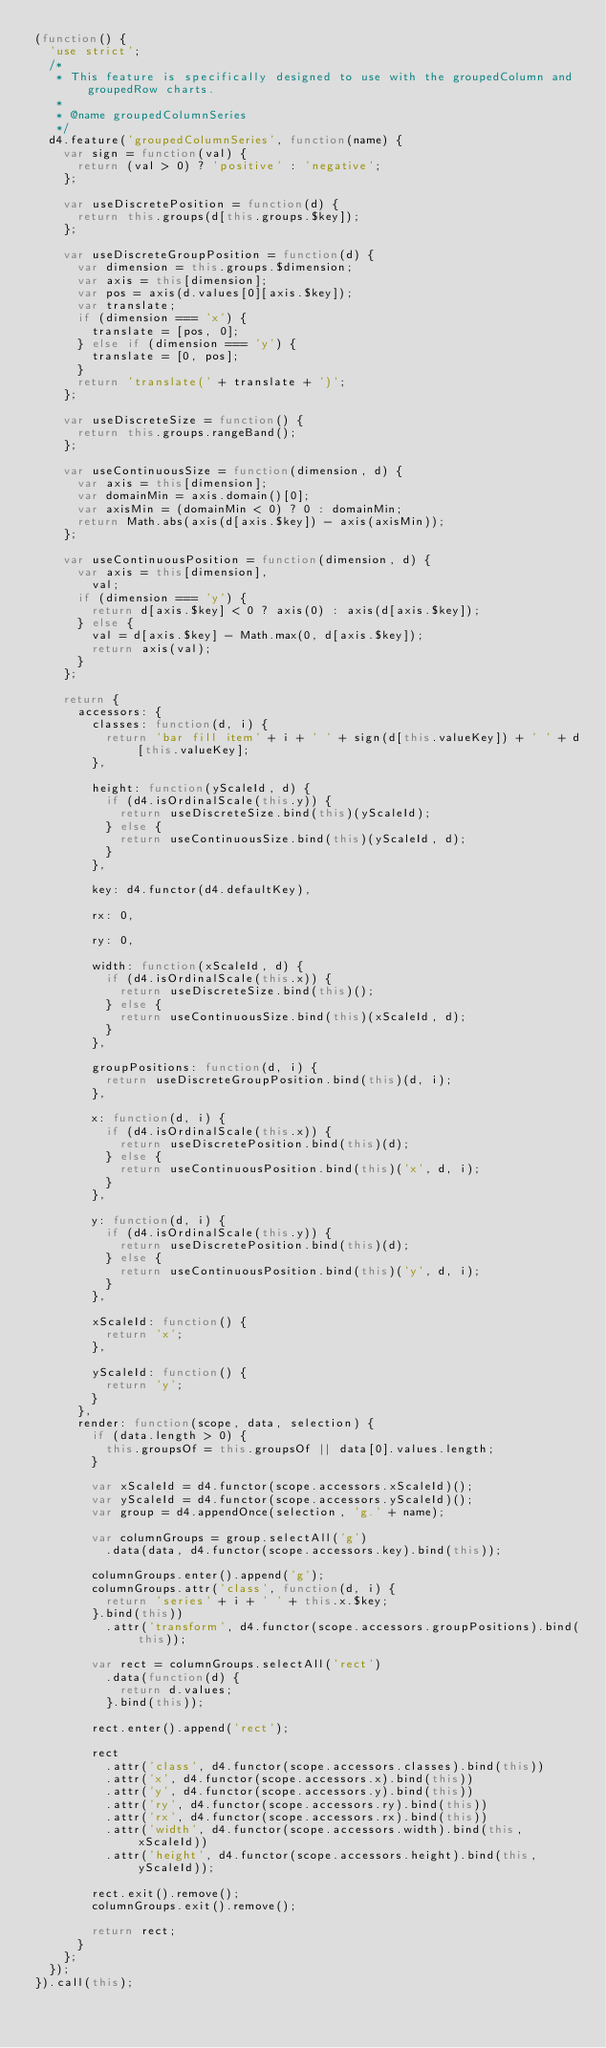<code> <loc_0><loc_0><loc_500><loc_500><_JavaScript_>(function() {
  'use strict';
  /*
   * This feature is specifically designed to use with the groupedColumn and groupedRow charts.
   *
   * @name groupedColumnSeries
   */
  d4.feature('groupedColumnSeries', function(name) {
    var sign = function(val) {
      return (val > 0) ? 'positive' : 'negative';
    };

    var useDiscretePosition = function(d) {
      return this.groups(d[this.groups.$key]);
    };

    var useDiscreteGroupPosition = function(d) {
      var dimension = this.groups.$dimension;
      var axis = this[dimension];
      var pos = axis(d.values[0][axis.$key]);
      var translate;
      if (dimension === 'x') {
        translate = [pos, 0];
      } else if (dimension === 'y') {
        translate = [0, pos];
      }
      return 'translate(' + translate + ')';
    };

    var useDiscreteSize = function() {
      return this.groups.rangeBand();
    };

    var useContinuousSize = function(dimension, d) {
      var axis = this[dimension];
      var domainMin = axis.domain()[0];
      var axisMin = (domainMin < 0) ? 0 : domainMin;
      return Math.abs(axis(d[axis.$key]) - axis(axisMin));
    };

    var useContinuousPosition = function(dimension, d) {
      var axis = this[dimension],
        val;
      if (dimension === 'y') {
        return d[axis.$key] < 0 ? axis(0) : axis(d[axis.$key]);
      } else {
        val = d[axis.$key] - Math.max(0, d[axis.$key]);
        return axis(val);
      }
    };

    return {
      accessors: {
        classes: function(d, i) {
          return 'bar fill item' + i + ' ' + sign(d[this.valueKey]) + ' ' + d[this.valueKey];
        },

        height: function(yScaleId, d) {
          if (d4.isOrdinalScale(this.y)) {
            return useDiscreteSize.bind(this)(yScaleId);
          } else {
            return useContinuousSize.bind(this)(yScaleId, d);
          }
        },

        key: d4.functor(d4.defaultKey),

        rx: 0,

        ry: 0,

        width: function(xScaleId, d) {
          if (d4.isOrdinalScale(this.x)) {
            return useDiscreteSize.bind(this)();
          } else {
            return useContinuousSize.bind(this)(xScaleId, d);
          }
        },

        groupPositions: function(d, i) {
          return useDiscreteGroupPosition.bind(this)(d, i);
        },

        x: function(d, i) {
          if (d4.isOrdinalScale(this.x)) {
            return useDiscretePosition.bind(this)(d);
          } else {
            return useContinuousPosition.bind(this)('x', d, i);
          }
        },

        y: function(d, i) {
          if (d4.isOrdinalScale(this.y)) {
            return useDiscretePosition.bind(this)(d);
          } else {
            return useContinuousPosition.bind(this)('y', d, i);
          }
        },

        xScaleId: function() {
          return 'x';
        },

        yScaleId: function() {
          return 'y';
        }
      },
      render: function(scope, data, selection) {
        if (data.length > 0) {
          this.groupsOf = this.groupsOf || data[0].values.length;
        }

        var xScaleId = d4.functor(scope.accessors.xScaleId)();
        var yScaleId = d4.functor(scope.accessors.yScaleId)();
        var group = d4.appendOnce(selection, 'g.' + name);

        var columnGroups = group.selectAll('g')
          .data(data, d4.functor(scope.accessors.key).bind(this));

        columnGroups.enter().append('g');
        columnGroups.attr('class', function(d, i) {
          return 'series' + i + ' ' + this.x.$key;
        }.bind(this))
          .attr('transform', d4.functor(scope.accessors.groupPositions).bind(this));

        var rect = columnGroups.selectAll('rect')
          .data(function(d) {
            return d.values;
          }.bind(this));

        rect.enter().append('rect');

        rect
          .attr('class', d4.functor(scope.accessors.classes).bind(this))
          .attr('x', d4.functor(scope.accessors.x).bind(this))
          .attr('y', d4.functor(scope.accessors.y).bind(this))
          .attr('ry', d4.functor(scope.accessors.ry).bind(this))
          .attr('rx', d4.functor(scope.accessors.rx).bind(this))
          .attr('width', d4.functor(scope.accessors.width).bind(this, xScaleId))
          .attr('height', d4.functor(scope.accessors.height).bind(this, yScaleId));

        rect.exit().remove();
        columnGroups.exit().remove();

        return rect;
      }
    };
  });
}).call(this);
</code> 